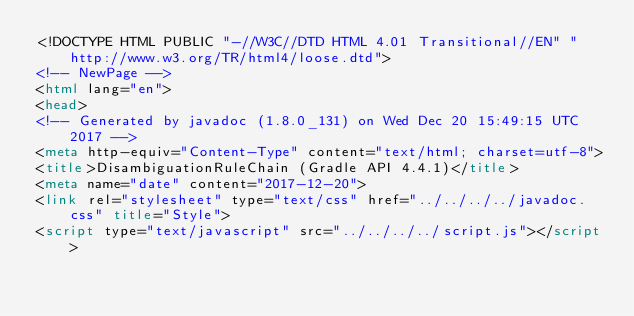Convert code to text. <code><loc_0><loc_0><loc_500><loc_500><_HTML_><!DOCTYPE HTML PUBLIC "-//W3C//DTD HTML 4.01 Transitional//EN" "http://www.w3.org/TR/html4/loose.dtd">
<!-- NewPage -->
<html lang="en">
<head>
<!-- Generated by javadoc (1.8.0_131) on Wed Dec 20 15:49:15 UTC 2017 -->
<meta http-equiv="Content-Type" content="text/html; charset=utf-8">
<title>DisambiguationRuleChain (Gradle API 4.4.1)</title>
<meta name="date" content="2017-12-20">
<link rel="stylesheet" type="text/css" href="../../../../javadoc.css" title="Style">
<script type="text/javascript" src="../../../../script.js"></script></code> 